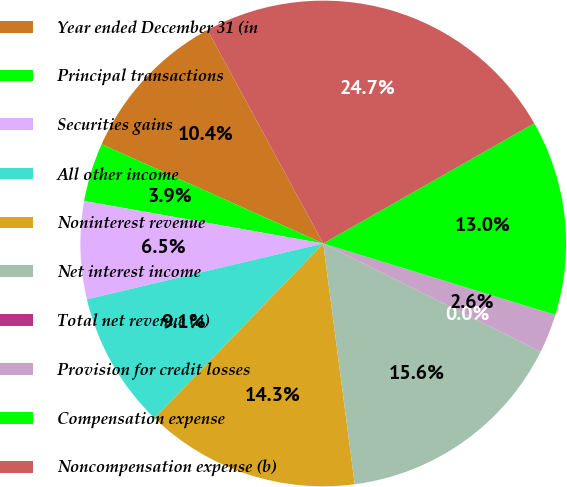<chart> <loc_0><loc_0><loc_500><loc_500><pie_chart><fcel>Year ended December 31 (in<fcel>Principal transactions<fcel>Securities gains<fcel>All other income<fcel>Noninterest revenue<fcel>Net interest income<fcel>Total net revenue (a)<fcel>Provision for credit losses<fcel>Compensation expense<fcel>Noncompensation expense (b)<nl><fcel>10.39%<fcel>3.9%<fcel>6.49%<fcel>9.09%<fcel>14.29%<fcel>15.58%<fcel>0.0%<fcel>2.6%<fcel>12.99%<fcel>24.67%<nl></chart> 